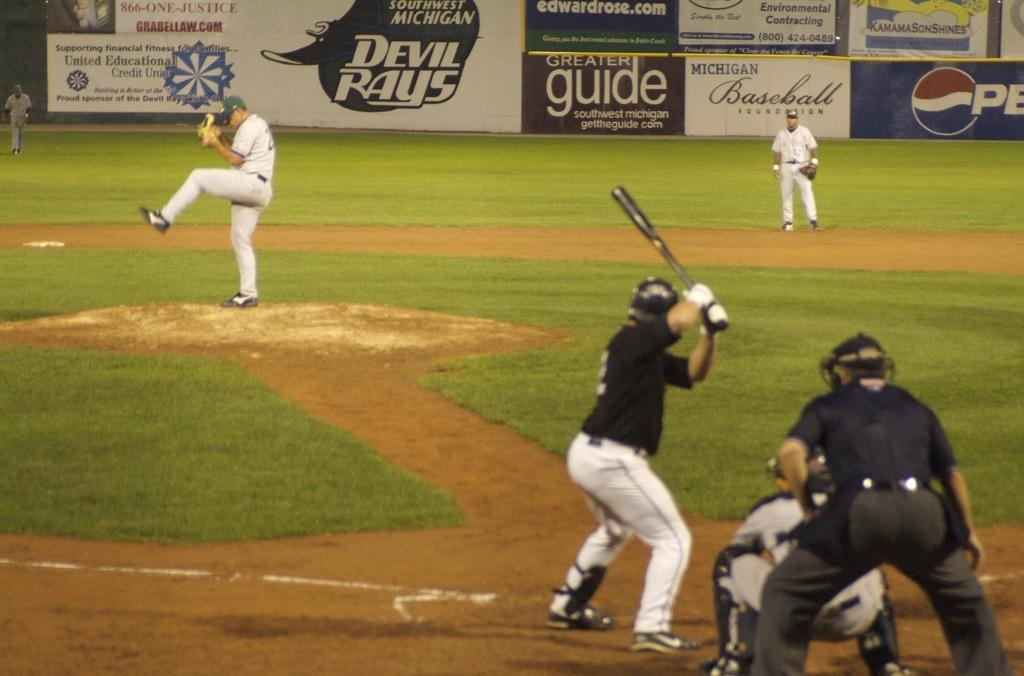<image>
Create a compact narrative representing the image presented. A baseball game takes place at the Devil Rays baseball field. 